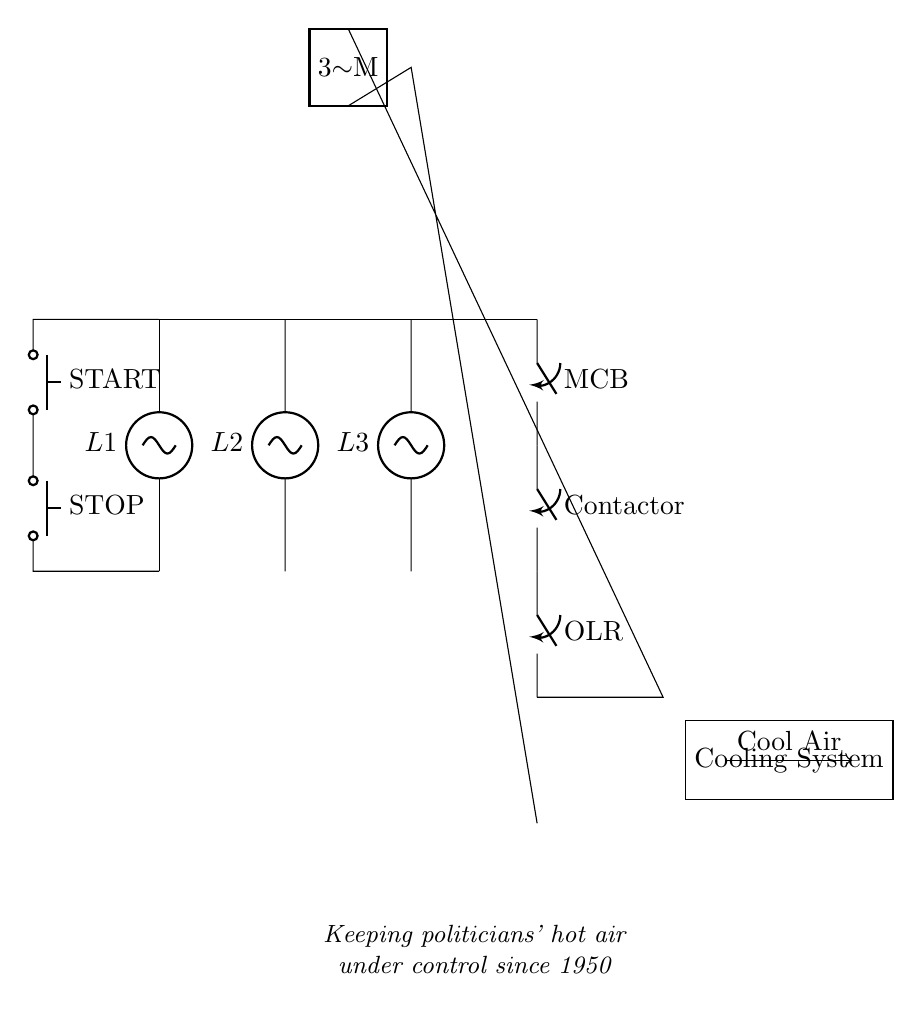What is the type of power supply used in this circuit? The circuit uses a three-phase power supply, as indicated by the three voltage sources labeled L1, L2, and L3 connected in parallel.
Answer: three-phase What is the function of the main circuit breaker? The main circuit breaker (labeled MCB) is designed to protect the circuit from overload or short-circuit conditions by breaking the circuit when necessary.
Answer: protect circuit How many push buttons are in the control circuit? There are two push buttons: one labeled START and one labeled STOP, which allow for manual operation of the motor.
Answer: two What component is used to prevent overheating of the motor? The thermal overload relay (labeled OLR) is used to prevent overheating by disconnecting the motor in case of excessive current.
Answer: thermal overload relay Why is it ironic to say this circuit controls politicians' hot air? The comment plays on the idea that a cooling system is needed to manage excessive heat, while politicians often create 'hot air' through speech and debate, highlighting the disconnect between the circuit's real purpose and the political context.
Answer: irony in commentary 